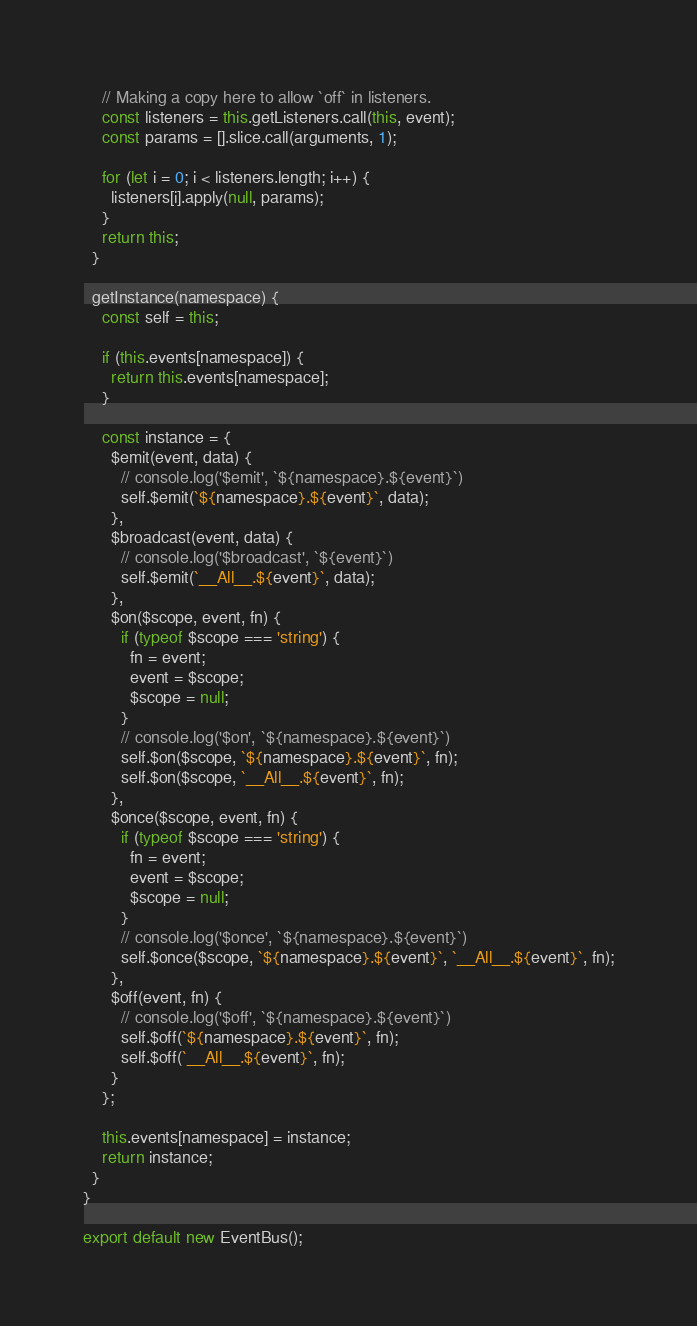<code> <loc_0><loc_0><loc_500><loc_500><_JavaScript_>
    // Making a copy here to allow `off` in listeners.
    const listeners = this.getListeners.call(this, event);
    const params = [].slice.call(arguments, 1);

    for (let i = 0; i < listeners.length; i++) {
      listeners[i].apply(null, params);
    }
    return this;
  }

  getInstance(namespace) {
    const self = this;

    if (this.events[namespace]) {
      return this.events[namespace];
    }

    const instance = {
      $emit(event, data) {
        // console.log('$emit', `${namespace}.${event}`)
        self.$emit(`${namespace}.${event}`, data);
      },
      $broadcast(event, data) {
        // console.log('$broadcast', `${event}`)
        self.$emit(`__All__.${event}`, data);
      },
      $on($scope, event, fn) {
        if (typeof $scope === 'string') {
          fn = event;
          event = $scope;
          $scope = null;
        }
        // console.log('$on', `${namespace}.${event}`)
        self.$on($scope, `${namespace}.${event}`, fn);
        self.$on($scope, `__All__.${event}`, fn);
      },
      $once($scope, event, fn) {
        if (typeof $scope === 'string') {
          fn = event;
          event = $scope;
          $scope = null;
        }
        // console.log('$once', `${namespace}.${event}`)
        self.$once($scope, `${namespace}.${event}`, `__All__.${event}`, fn);
      },
      $off(event, fn) {
        // console.log('$off', `${namespace}.${event}`)
        self.$off(`${namespace}.${event}`, fn);
        self.$off(`__All__.${event}`, fn);
      }
    };

    this.events[namespace] = instance;
    return instance;
  }
}

export default new EventBus();
</code> 